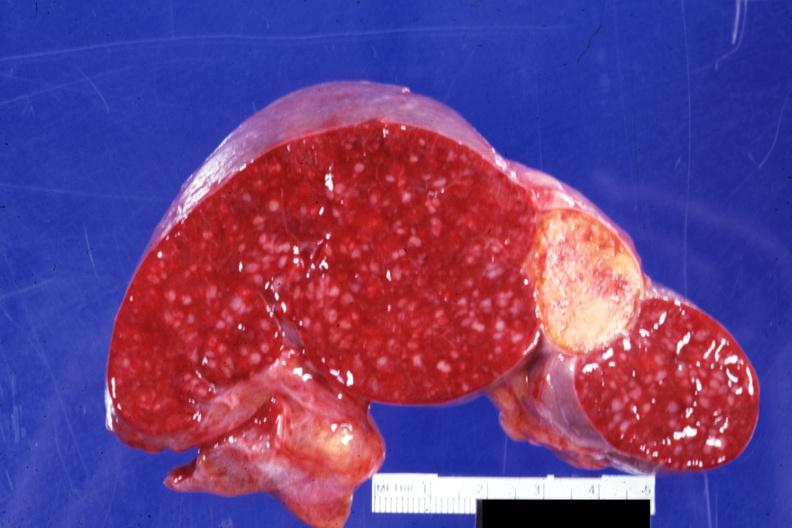where is this part in?
Answer the question using a single word or phrase. Spleen 